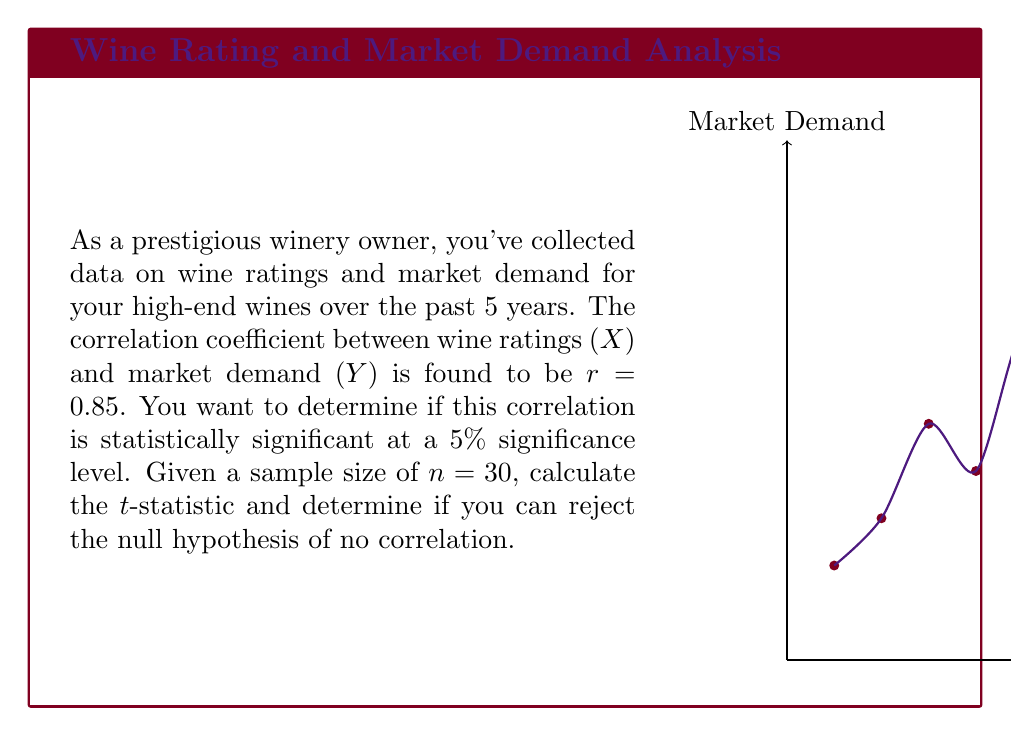Teach me how to tackle this problem. To determine if the correlation is statistically significant, we'll follow these steps:

1) First, we need to calculate the t-statistic using the formula:

   $$t = \frac{r\sqrt{n-2}}{\sqrt{1-r^2}}$$

   where r is the correlation coefficient and n is the sample size.

2) Substituting our values:
   
   $$t = \frac{0.85\sqrt{30-2}}{\sqrt{1-0.85^2}}$$

3) Simplify:
   
   $$t = \frac{0.85\sqrt{28}}{\sqrt{1-0.7225}} = \frac{0.85 * 5.2915}{\sqrt{0.2775}}$$

4) Calculate:
   
   $$t = \frac{4.4978}{0.5268} \approx 8.5380$$

5) For a two-tailed test at 5% significance level with 28 degrees of freedom (n-2), the critical t-value is approximately ±2.048 (from t-distribution table).

6) Since our calculated t-statistic (8.5380) is greater than the critical value (2.048), we reject the null hypothesis.

Therefore, we can conclude that there is a statistically significant correlation between wine ratings and market demand at the 5% significance level.
Answer: Reject null hypothesis; correlation is statistically significant (t ≈ 8.5380 > 2.048) 